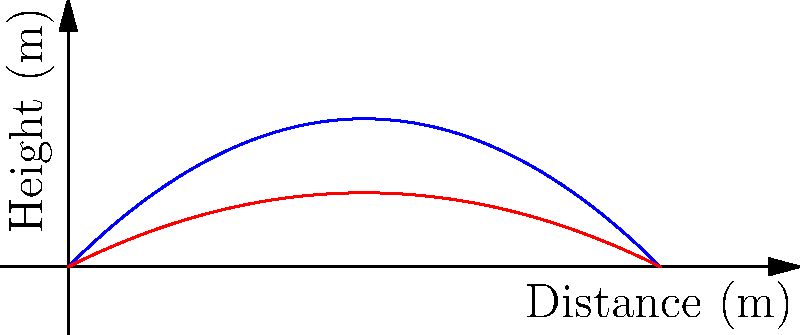As a hockey player, you know that the angle at which you shoot the puck affects its trajectory. The graph shows the trajectories of two shots: one at a 45° angle (blue) and another at a 30° angle (red). Both shots have the same initial velocity. Which shot will travel farther horizontally, and why? To determine which shot will travel farther horizontally, we need to analyze the trajectories:

1. The blue curve represents the 45° shot, while the red curve represents the 30° shot.

2. In projectile motion, the horizontal distance traveled depends on two factors:
   a) Initial velocity (which is the same for both shots in this case)
   b) Time of flight

3. The time of flight is determined by how long the puck stays in the air before hitting the ground.

4. Observe that the 30° shot (red) has a lower maximum height compared to the 45° shot (blue).

5. Due to its lower trajectory, the 30° shot spends less time in the air, which might seem counterintuitive for achieving a greater distance.

6. However, the 30° angle allows for a greater horizontal component of the initial velocity vector.

7. This greater horizontal component compensates for the shorter time of flight, resulting in a longer horizontal distance.

8. We can see from the graph that the red curve (30° shot) intersects the x-axis (ground level) further to the right than the blue curve (45° shot).

9. The 30° shot reaches the ground at approximately 10 meters, while the 45° shot lands at about 9.5 meters.

Therefore, the 30° shot travels farther horizontally despite having a lower maximum height and shorter time of flight.
Answer: The 30° shot travels farther horizontally due to its greater horizontal velocity component. 